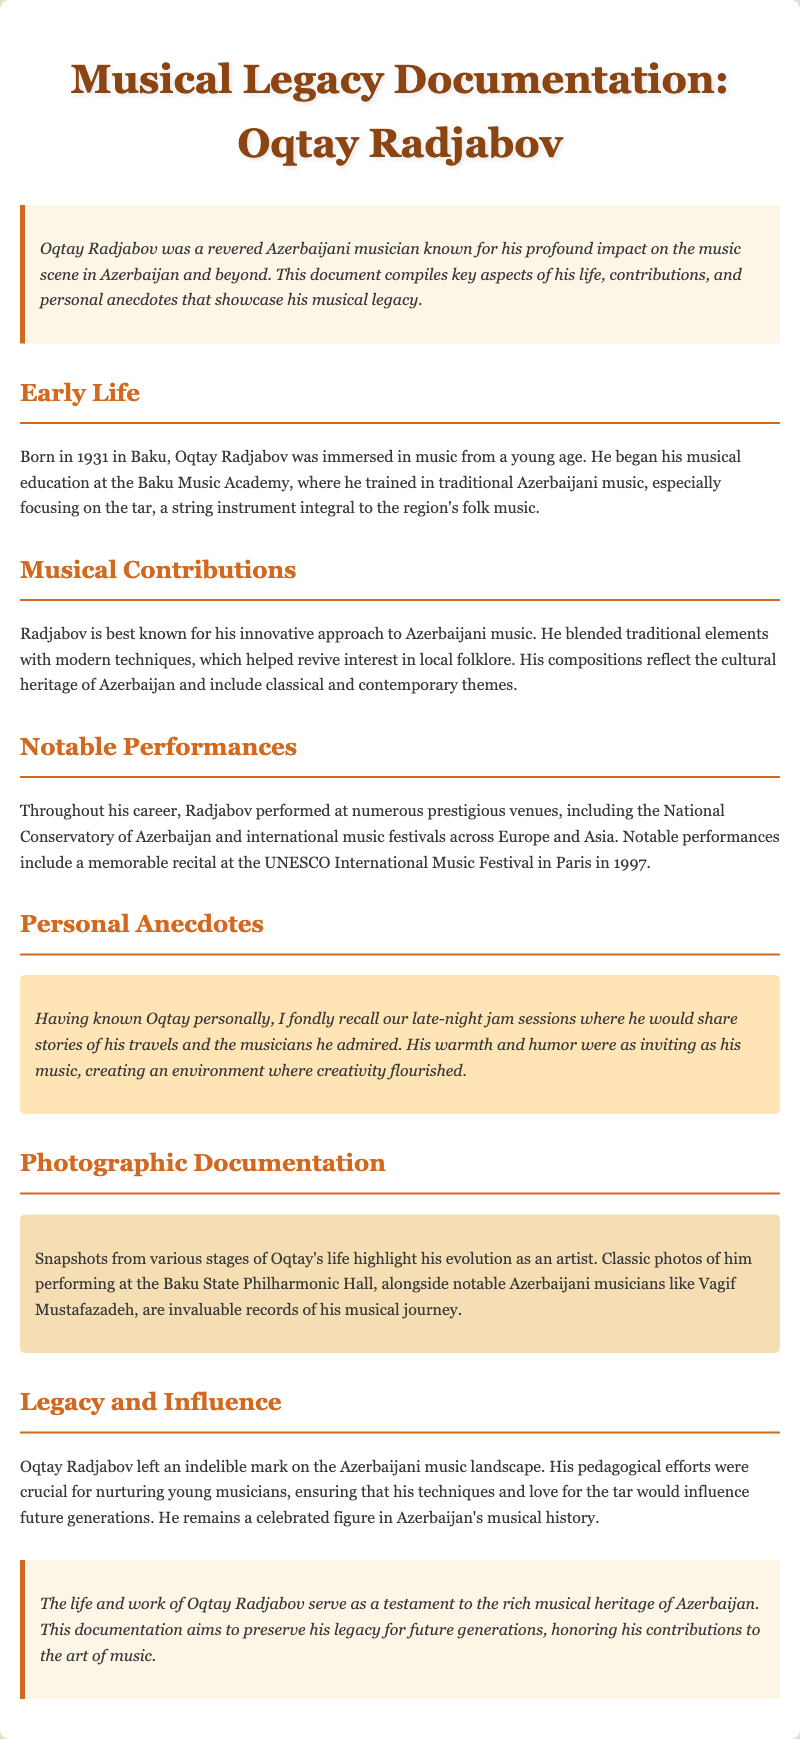What year was Oqtay Radjabov born? The document states that Oqtay Radjabov was born in 1931.
Answer: 1931 What instrument did Oqtay Radjabov focus on? The document mentions that he focused on the tar, a string instrument integral to the region's folk music.
Answer: tar Where did Oqtay perform in 1997? The document indicates that he performed at the UNESCO International Music Festival in Paris in 1997.
Answer: Paris What type of music did Radjabov blend in his compositions? The document notes that Radjabov blended traditional elements with modern techniques.
Answer: traditional and modern Which notable musician is mentioned alongside Oqtay in the document? The document mentions Vagif Mustafazadeh as a notable Azerbaijani musician.
Answer: Vagif Mustafazadeh How is Oqtay's influence described regarding future generations? The document states that his pedagogical efforts were crucial for nurturing young musicians.
Answer: nurturing young musicians What is the purpose of this documentation? The document explains that the purpose is to preserve Oqtay Radjabov's legacy for future generations.
Answer: preserve his legacy In what year was the UNESCO International Music Festival mentioned? The document specifies that the performance at the festival took place in the year 1997.
Answer: 1997 